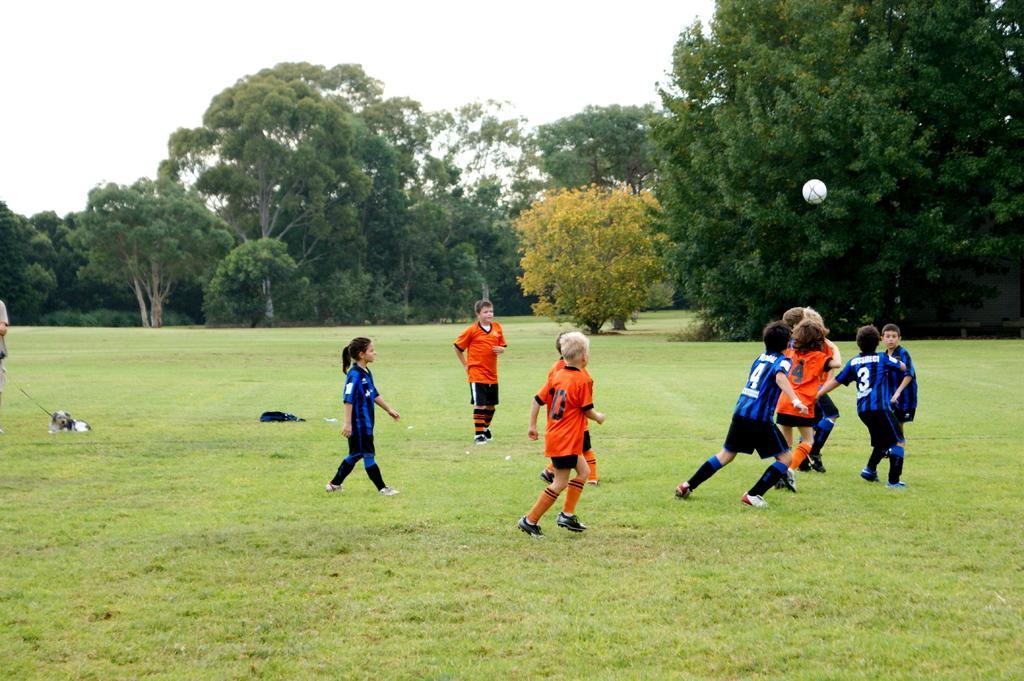In one or two sentences, can you explain what this image depicts? In this image children's are playing in the garden, in the background there are trees. 